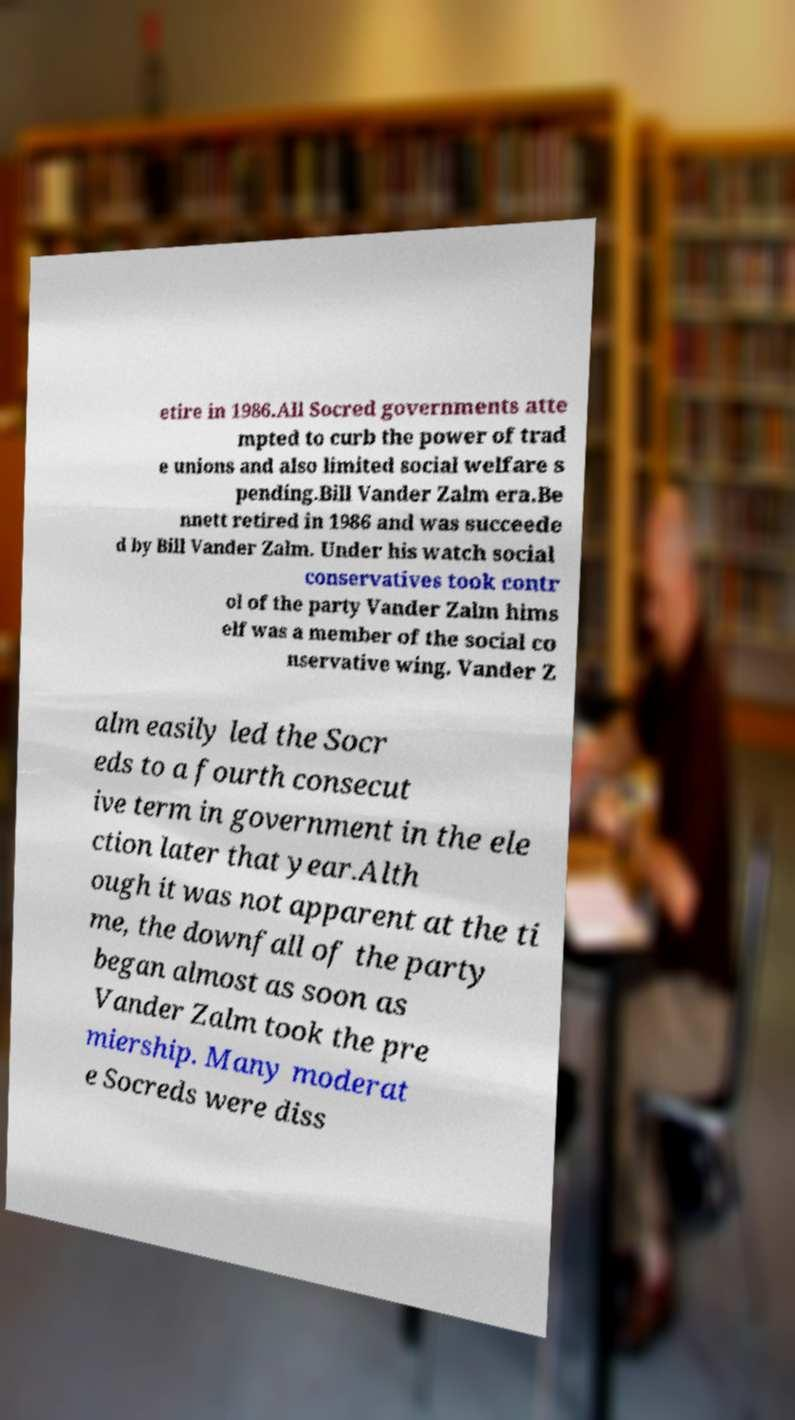Can you read and provide the text displayed in the image?This photo seems to have some interesting text. Can you extract and type it out for me? etire in 1986.All Socred governments atte mpted to curb the power of trad e unions and also limited social welfare s pending.Bill Vander Zalm era.Be nnett retired in 1986 and was succeede d by Bill Vander Zalm. Under his watch social conservatives took contr ol of the party Vander Zalm hims elf was a member of the social co nservative wing. Vander Z alm easily led the Socr eds to a fourth consecut ive term in government in the ele ction later that year.Alth ough it was not apparent at the ti me, the downfall of the party began almost as soon as Vander Zalm took the pre miership. Many moderat e Socreds were diss 